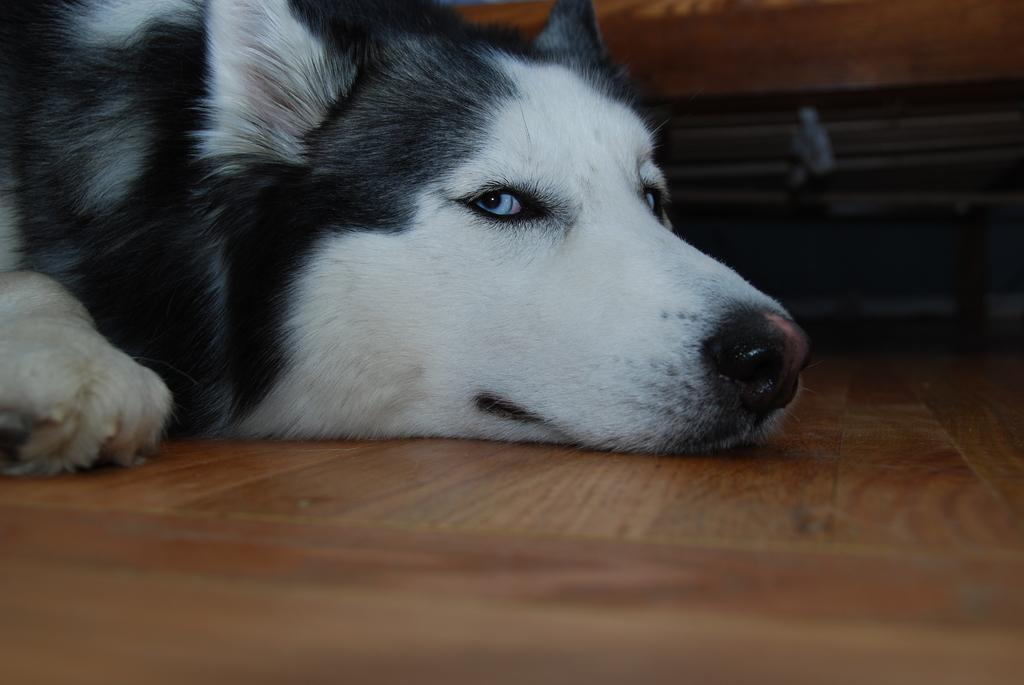What type of animal is present in the image? There is a dog in the image. What is the dog doing in the image? The dog is laying on the wooden floor. How many legs does the drawer have in the image? There is no drawer present in the image, so it is not possible to determine how many legs it might have. 